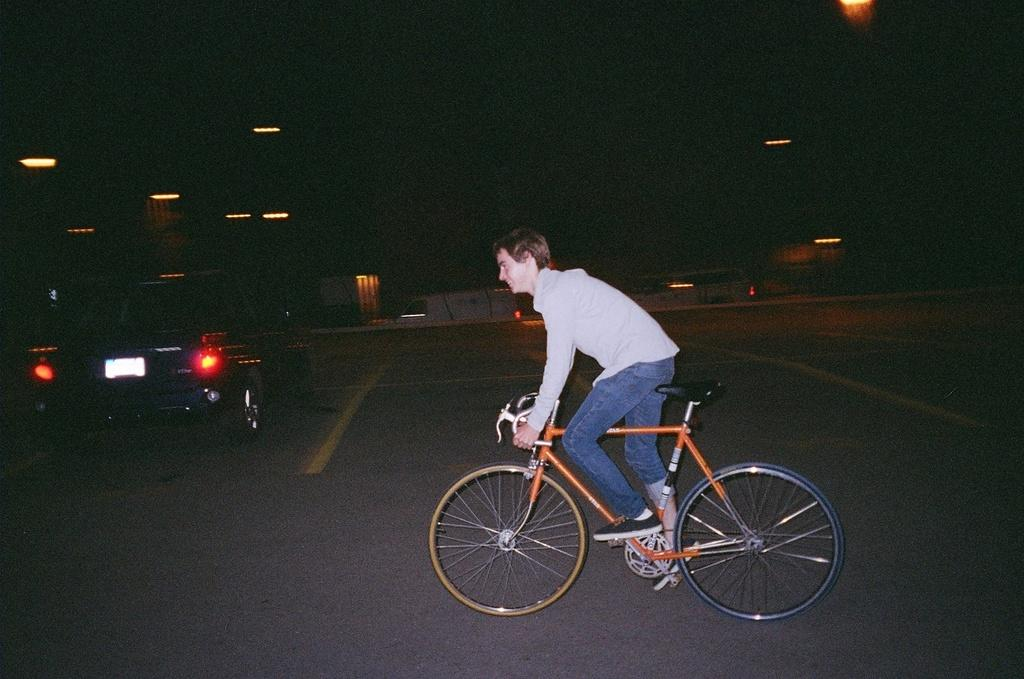What is the main subject of the image? There is a person riding a bicycle in the image. What else can be seen in the image besides the person on the bicycle? There is a car and houses in the image. Are there any other objects or features in the image? Yes, there are lights in the image. How would you describe the overall appearance of the image? The background of the image is dark. How much debt does the person riding the bicycle have in the image? There is no information about the person's debt in the image. What type of pain is the person on the bicycle experiencing in the image? There is no indication of pain or any physical discomfort for the person in the image. 